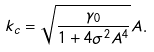<formula> <loc_0><loc_0><loc_500><loc_500>k _ { c } = \sqrt { \frac { \gamma _ { 0 } } { 1 + 4 \sigma ^ { 2 } A ^ { 4 } } } A .</formula> 